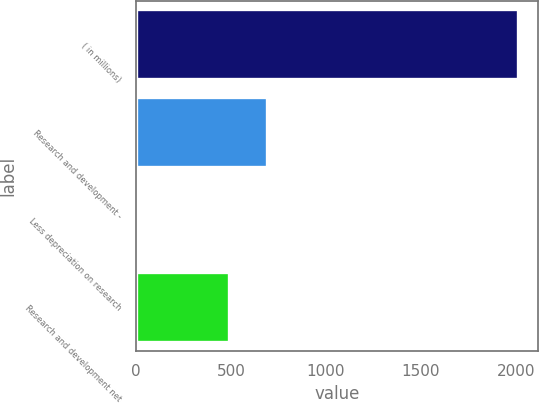Convert chart. <chart><loc_0><loc_0><loc_500><loc_500><bar_chart><fcel>( in millions)<fcel>Research and development -<fcel>Less depreciation on research<fcel>Research and development net<nl><fcel>2014<fcel>691.7<fcel>17<fcel>492<nl></chart> 